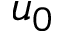Convert formula to latex. <formula><loc_0><loc_0><loc_500><loc_500>u _ { 0 }</formula> 